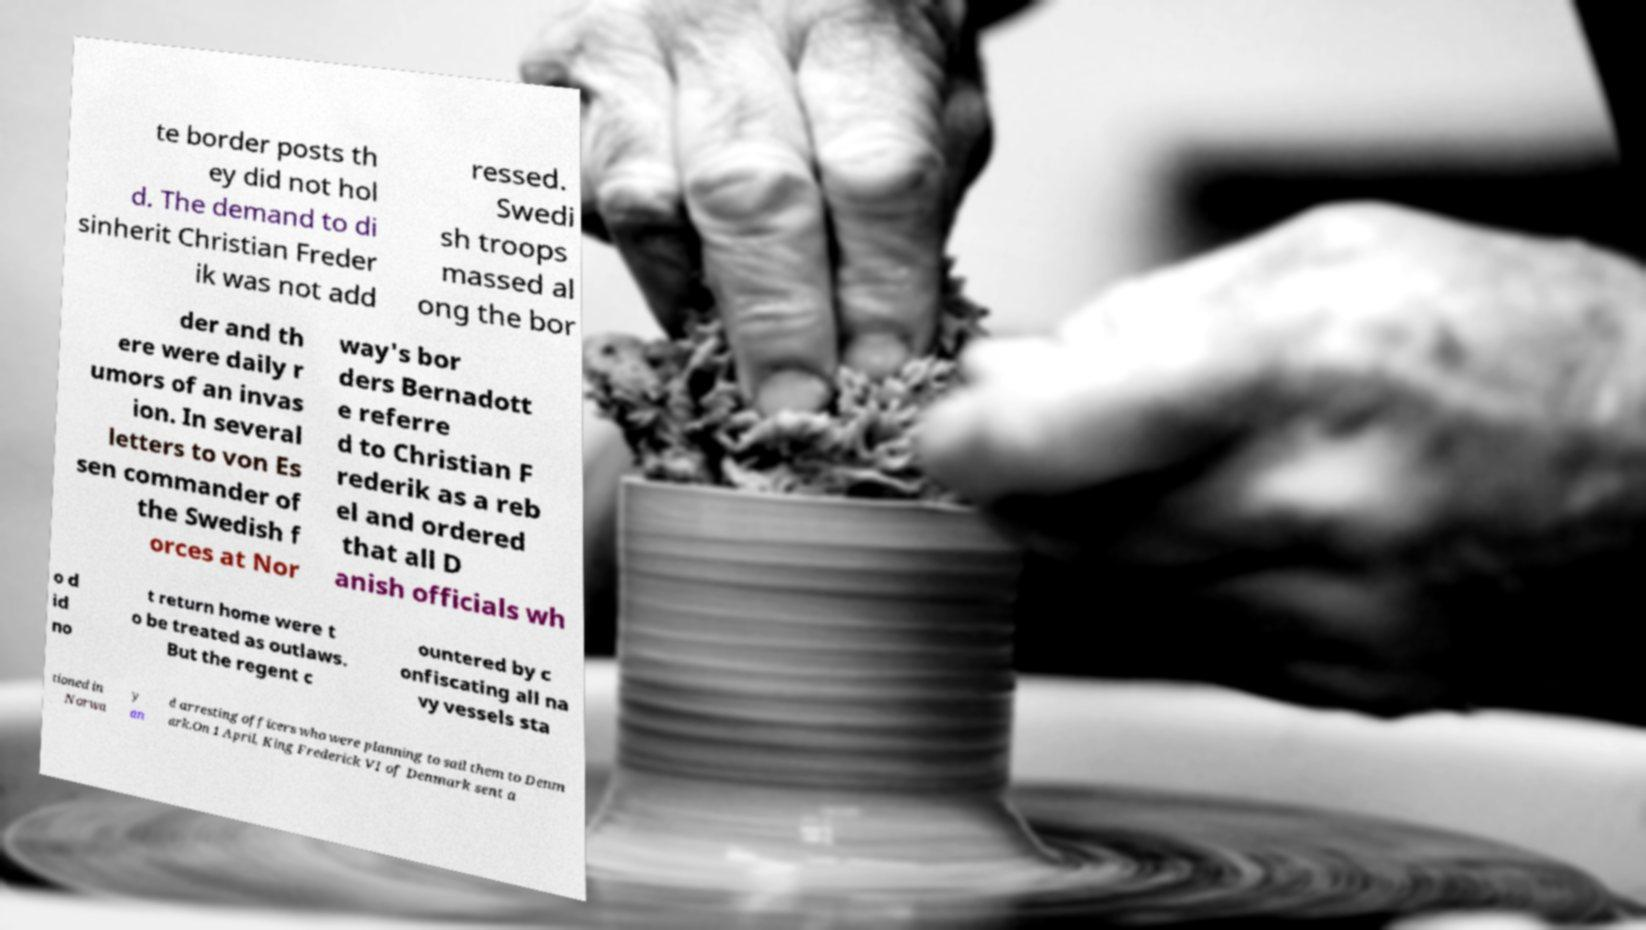What messages or text are displayed in this image? I need them in a readable, typed format. te border posts th ey did not hol d. The demand to di sinherit Christian Freder ik was not add ressed. Swedi sh troops massed al ong the bor der and th ere were daily r umors of an invas ion. In several letters to von Es sen commander of the Swedish f orces at Nor way's bor ders Bernadott e referre d to Christian F rederik as a reb el and ordered that all D anish officials wh o d id no t return home were t o be treated as outlaws. But the regent c ountered by c onfiscating all na vy vessels sta tioned in Norwa y an d arresting officers who were planning to sail them to Denm ark.On 1 April, King Frederick VI of Denmark sent a 